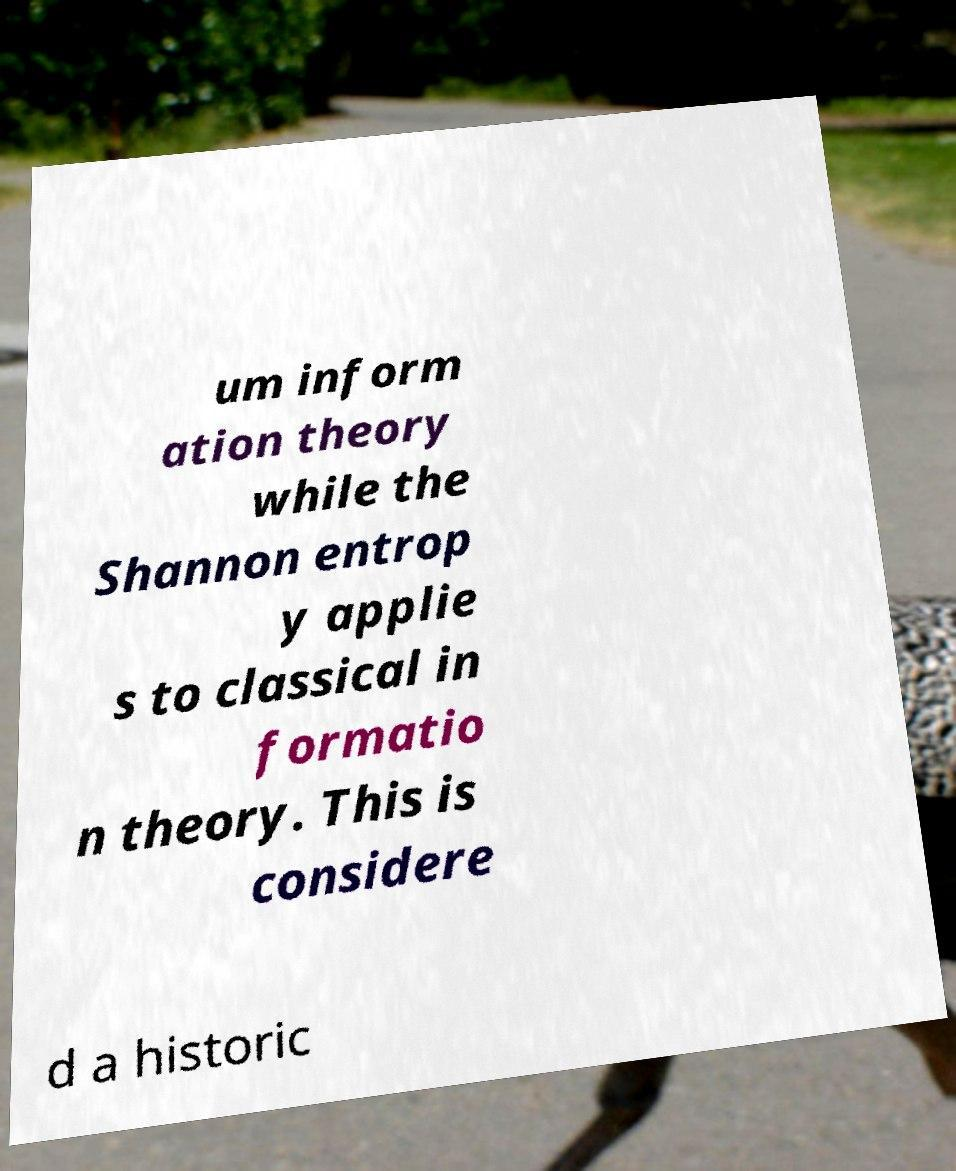Could you assist in decoding the text presented in this image and type it out clearly? um inform ation theory while the Shannon entrop y applie s to classical in formatio n theory. This is considere d a historic 